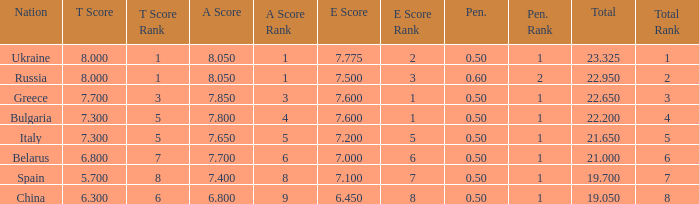What E score has the T score of 8 and a number smaller than 22.95? None. 